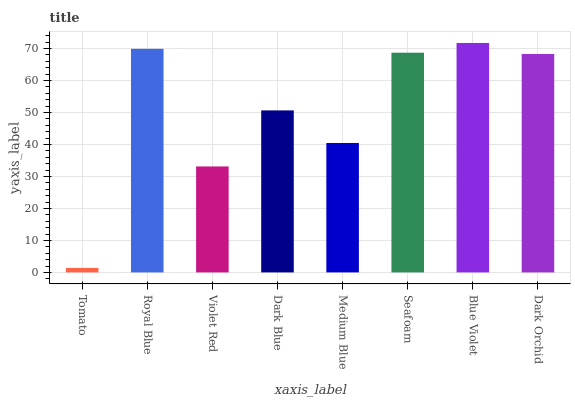Is Tomato the minimum?
Answer yes or no. Yes. Is Blue Violet the maximum?
Answer yes or no. Yes. Is Royal Blue the minimum?
Answer yes or no. No. Is Royal Blue the maximum?
Answer yes or no. No. Is Royal Blue greater than Tomato?
Answer yes or no. Yes. Is Tomato less than Royal Blue?
Answer yes or no. Yes. Is Tomato greater than Royal Blue?
Answer yes or no. No. Is Royal Blue less than Tomato?
Answer yes or no. No. Is Dark Orchid the high median?
Answer yes or no. Yes. Is Dark Blue the low median?
Answer yes or no. Yes. Is Dark Blue the high median?
Answer yes or no. No. Is Blue Violet the low median?
Answer yes or no. No. 